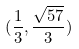Convert formula to latex. <formula><loc_0><loc_0><loc_500><loc_500>( \frac { 1 } { 3 } , \frac { \sqrt { 5 7 } } { 3 } )</formula> 